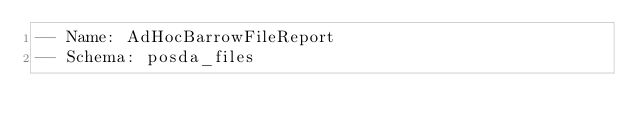Convert code to text. <code><loc_0><loc_0><loc_500><loc_500><_SQL_>-- Name: AdHocBarrowFileReport
-- Schema: posda_files</code> 